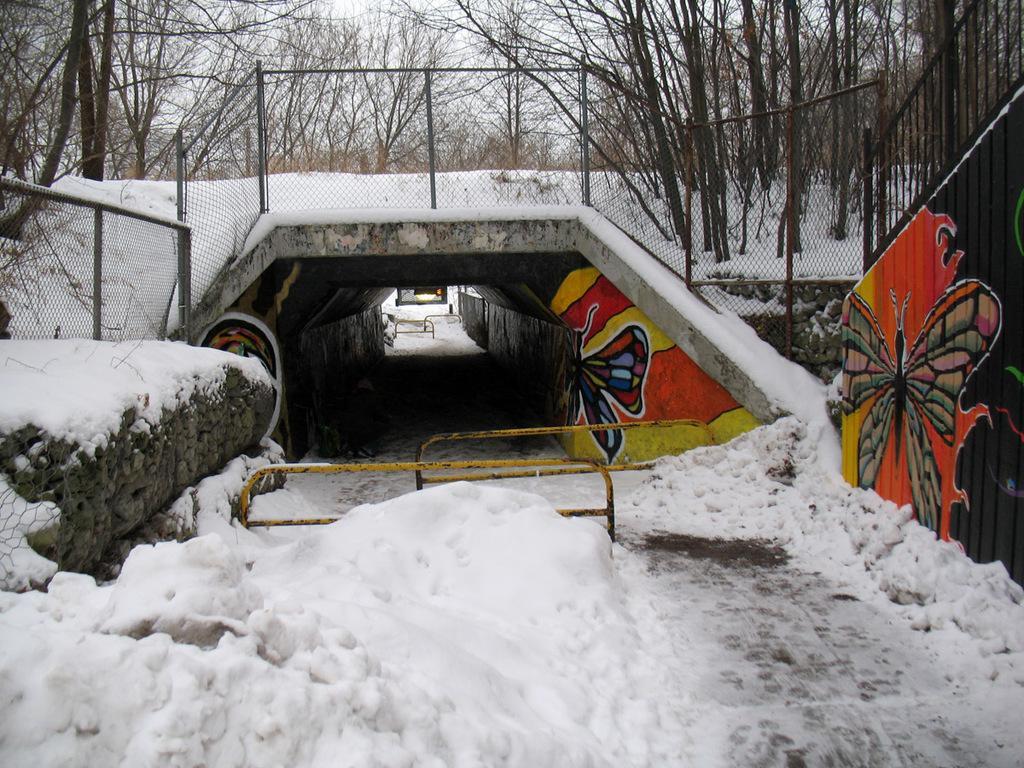Could you give a brief overview of what you see in this image? At bottom of the image I can see the snow. On the right side there is a railing. In the background there is a bridge and a net. In the background, I can see the trees. 